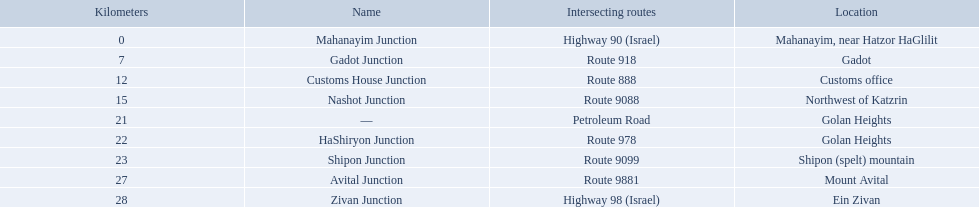Which junctions cross a route? Gadot Junction, Customs House Junction, Nashot Junction, HaShiryon Junction, Shipon Junction, Avital Junction. Which of these shares [art of its name with its locations name? Gadot Junction, Customs House Junction, Shipon Junction, Avital Junction. Which of them is not located in a locations named after a mountain? Gadot Junction, Customs House Junction. Which of these has the highest route number? Gadot Junction. What are all of the junction names? Mahanayim Junction, Gadot Junction, Customs House Junction, Nashot Junction, —, HaShiryon Junction, Shipon Junction, Avital Junction, Zivan Junction. What are their locations in kilometers? 0, 7, 12, 15, 21, 22, 23, 27, 28. Between shipon and avital, whicih is nashot closer to? Shipon Junction. 